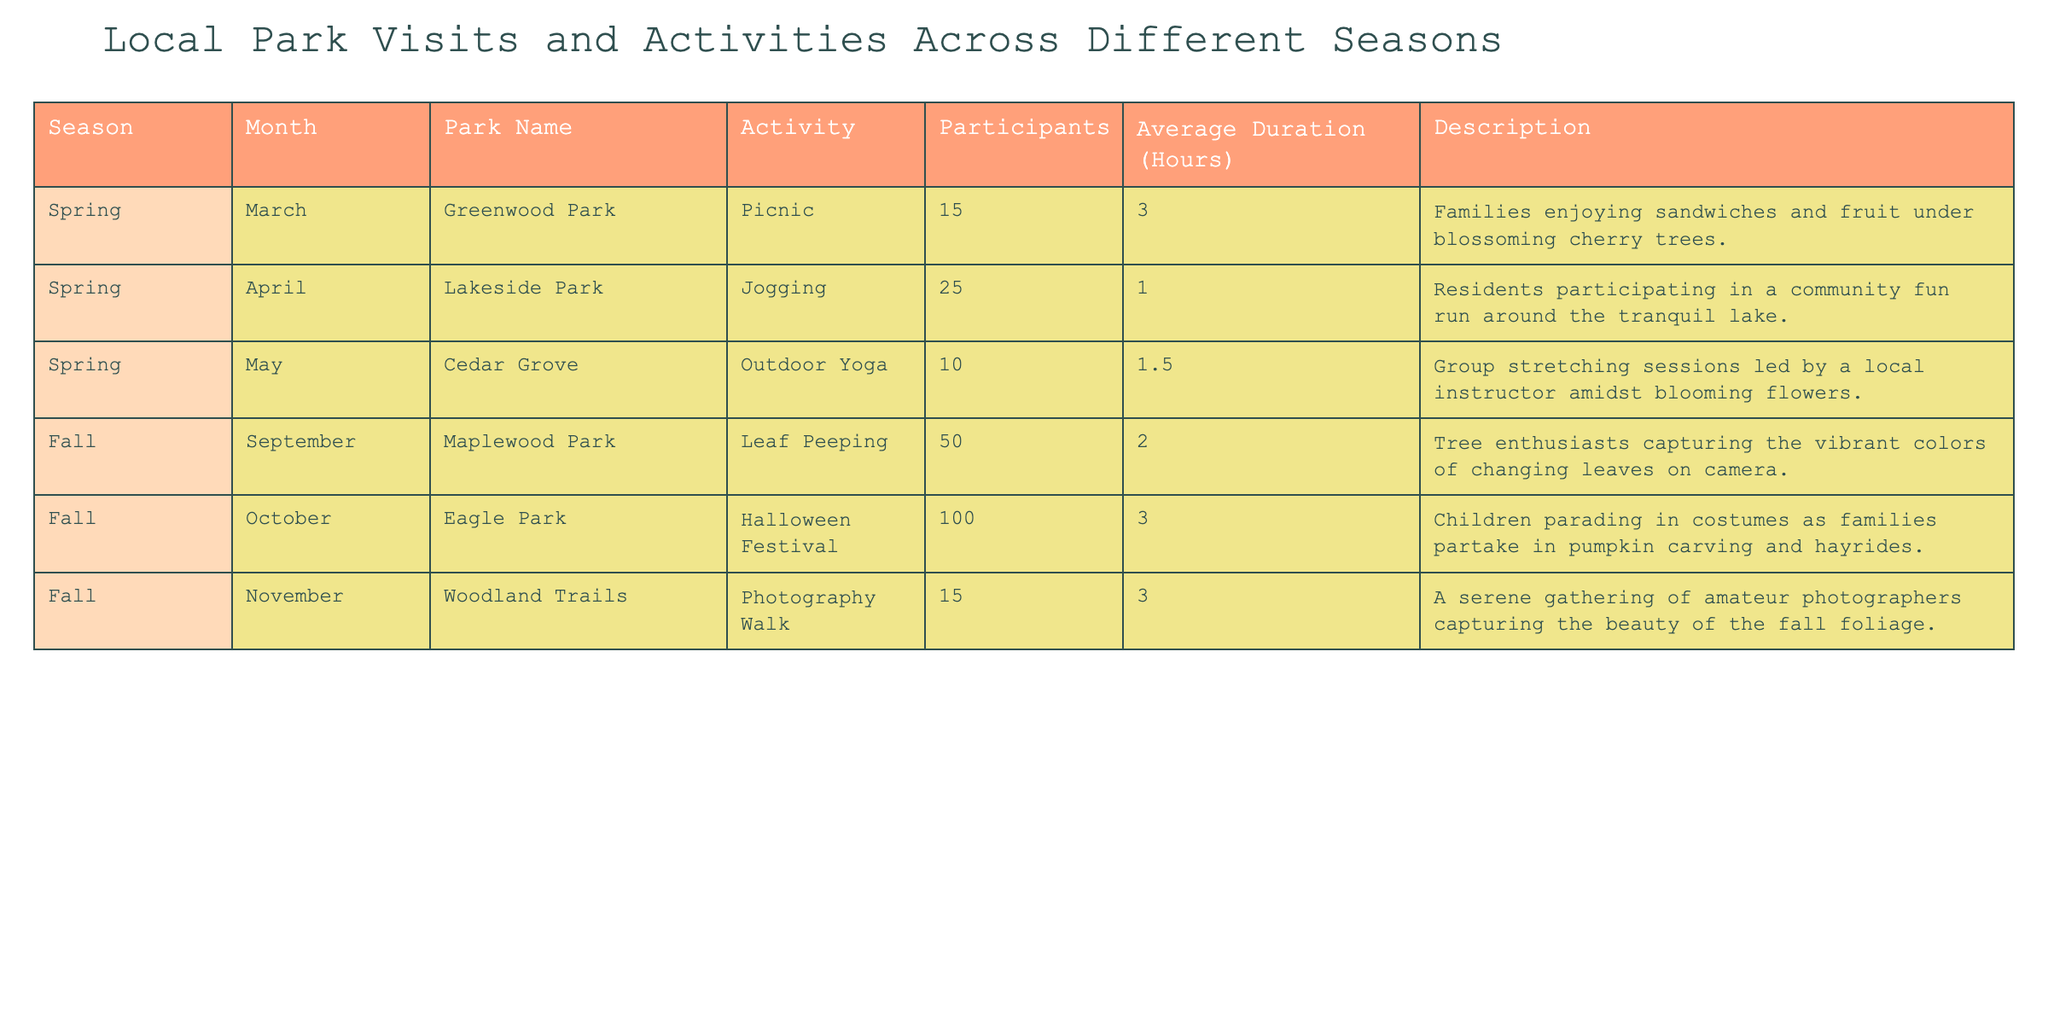What activity had the highest number of participants? From the table, we see that the Halloween Festival at Eagle Park in October had 100 participants, which is higher than any other activity listed.
Answer: 100 In which month were the least number of participants recorded? By examining the table, the activity with the least number of participants is Outdoor Yoga in May, with only 10 participants.
Answer: 10 What is the average duration of all activities listed? To calculate the average duration, we sum the durations: (3 + 1 + 1.5 + 2 + 3 + 3) = 14.5 hours. Then, divide by the number of activities, which is 6, resulting in an average of 14.5/6 = 2.42 hours.
Answer: 2.42 Which park had an activity involving photography, and how many participants did it attract? The table indicates that Woodland Trails hosted a Photography Walk in November, which attracted 15 participants.
Answer: 15 Is there a park where the activities are all related to the fall season? Yes, the table shows that Maplewood Park, Eagle Park, and Woodland Trails all have activities that take place in the fall season.
Answer: Yes What was the total number of participants across all activities in March and April? We find the activities for March (Picnic at Greenwood Park with 15 participants) and April (Jogging at Lakeside Park with 25 participants). Adding them gives 15 + 25 = 40 participants total in these months.
Answer: 40 Which activity had the longest average duration? From the table, we compare the average durations: Picnic (3 hours), Halloween Festival (3 hours), and Photography Walk (3 hours) are tied for the longest.
Answer: Picnic, Halloween Festival, and Photography Walk (all 3 hours) How many participants were involved in outdoor activities during the spring? Looking at the spring activities, there were 15 participants in the Picnic, 25 in Jogging, and 10 in Outdoor Yoga. Summing these gives 15 + 25 + 10 = 50 participants.
Answer: 50 How does the number of participants in the Halloween Festival compare to those in the other two fall activities? The Halloween Festival had 100 participants, whereas Leaf Peeping had 50 and Photography Walk had 15. Thus, 100 is significantly more than both, specifically 50 more than Leaf Peeping and 85 more than Photography Walk.
Answer: 100 (100 more than both) What was the most popular park in terms of participants? By checking the total participants for each park, Eagle Park had the most with 100 from the Halloween Festival, more than any other park's total.
Answer: Eagle Park 